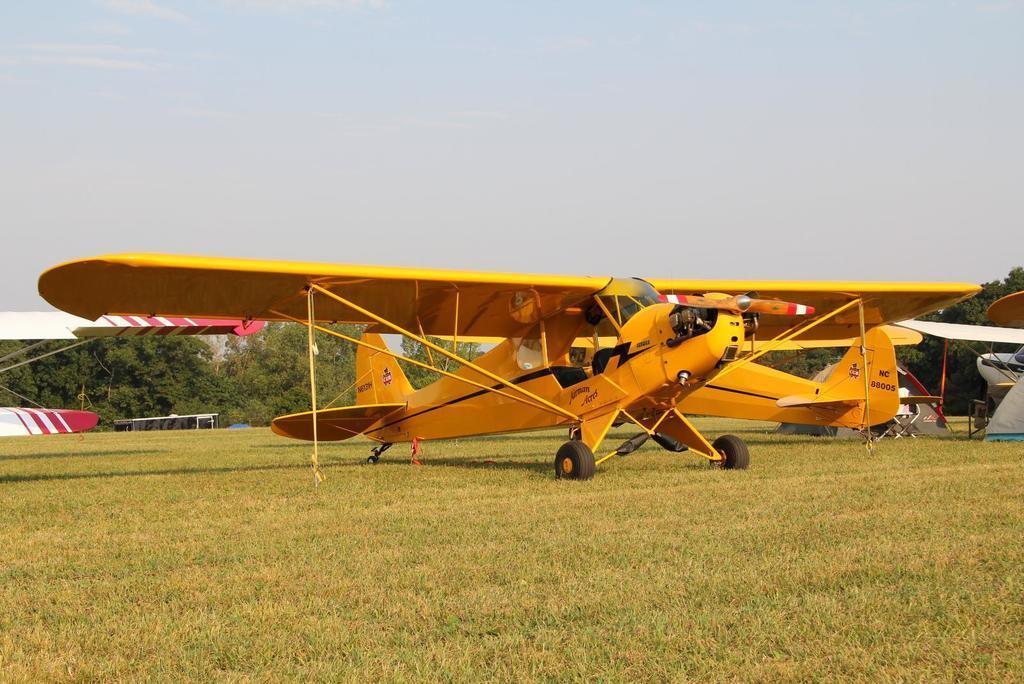Can you describe this image briefly? There are two yellow color aircraft parked on the grass on the ground near other aircraft. In the background, there are trees and clouds in the sky. 